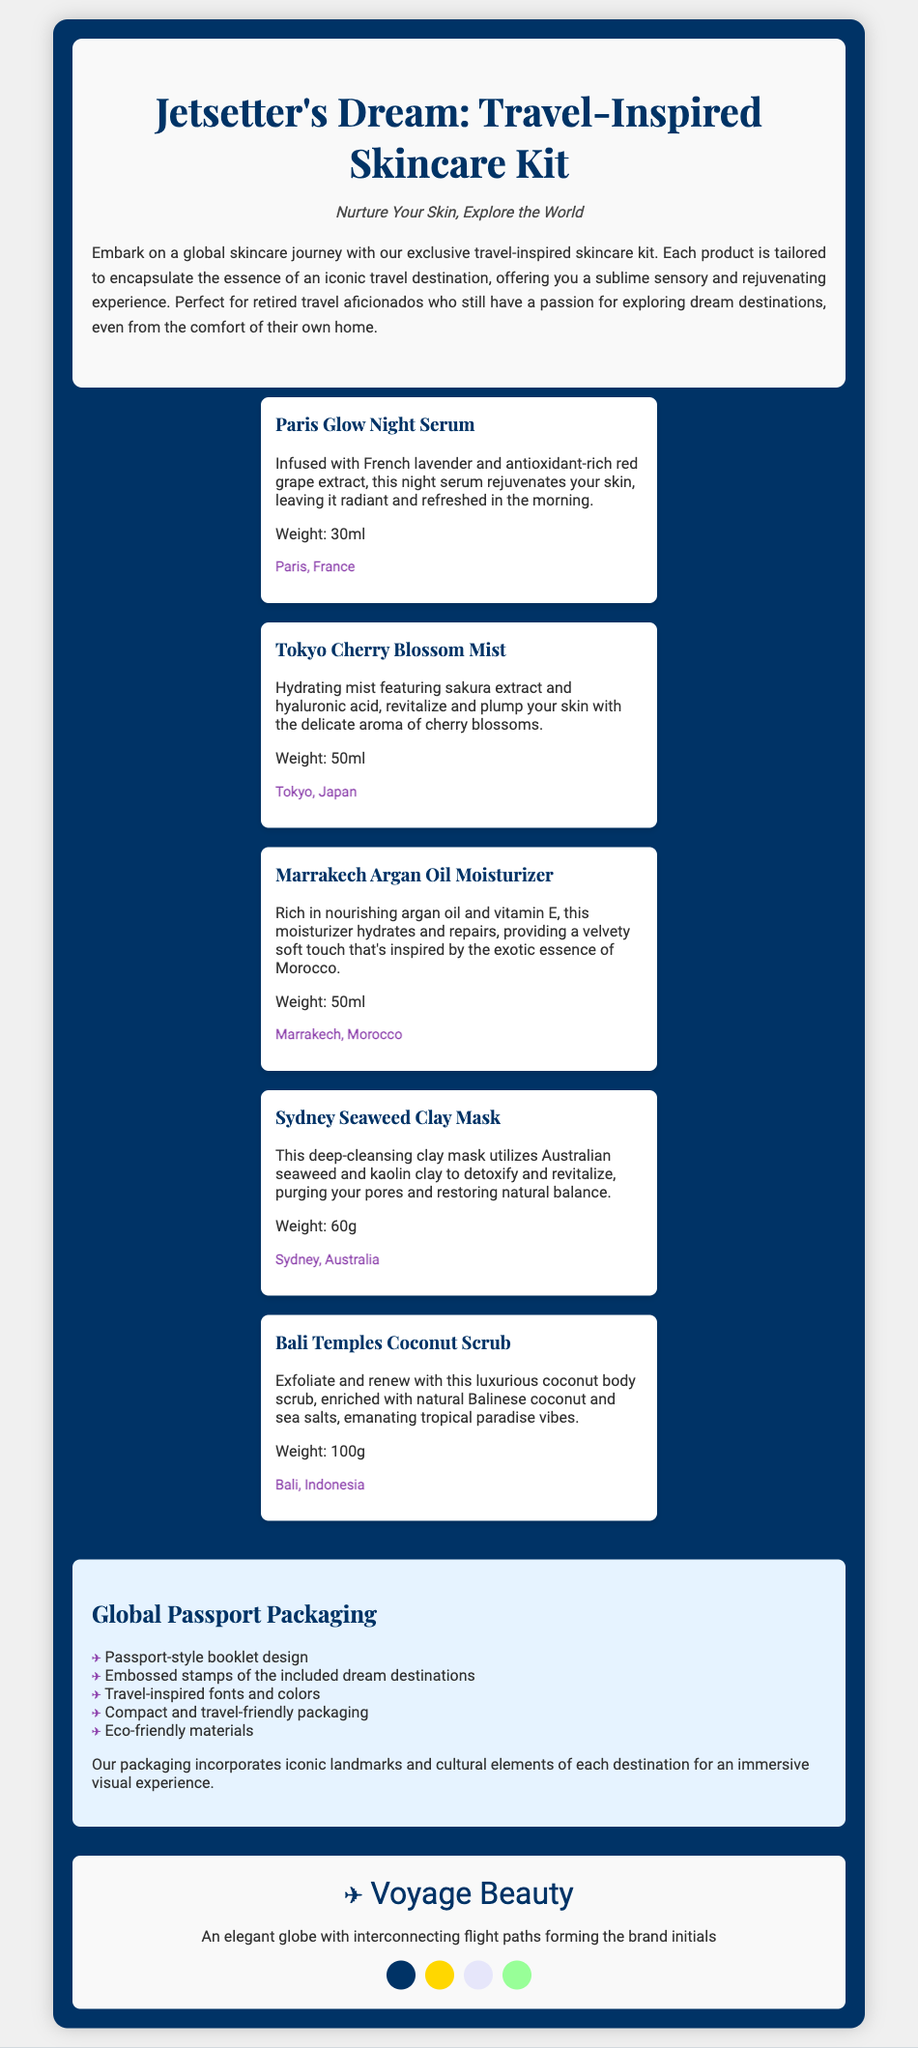What is the name of the skincare kit? The name of the kit is prominently displayed in the title of the document.
Answer: Jetsetter's Dream: Travel-Inspired Skincare Kit Which product features sakura extract? This information can be found in the product descriptions, specifically relating to the Tokyo product.
Answer: Tokyo Cherry Blossom Mist How many milliliters is the Paris Glow Night Serum? The weight of the serum is mentioned directly in its product description.
Answer: 30ml What is the packaging style of the product? The packaging design is described in a dedicated section, highlighting its unique aspects.
Answer: Passport-style booklet design How many products are featured in the skincare kit? The number of products can be counted from the product listing section of the document.
Answer: Five Which destination is associated with the coconut scrub? Each product description includes a specific destination linked to it.
Answer: Bali, Indonesia What color is used for the brand logo? The logo color is described in the branding section.
Answer: #003366 What is one of the eco-friendly features of the packaging? Features of the packaging are listed that highlight its environmentally conscious aspects.
Answer: Eco-friendly materials 